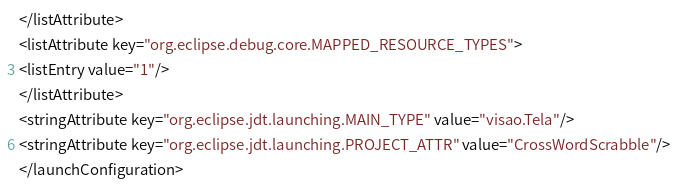Convert code to text. <code><loc_0><loc_0><loc_500><loc_500><_XML_></listAttribute>
<listAttribute key="org.eclipse.debug.core.MAPPED_RESOURCE_TYPES">
<listEntry value="1"/>
</listAttribute>
<stringAttribute key="org.eclipse.jdt.launching.MAIN_TYPE" value="visao.Tela"/>
<stringAttribute key="org.eclipse.jdt.launching.PROJECT_ATTR" value="CrossWordScrabble"/>
</launchConfiguration>
</code> 